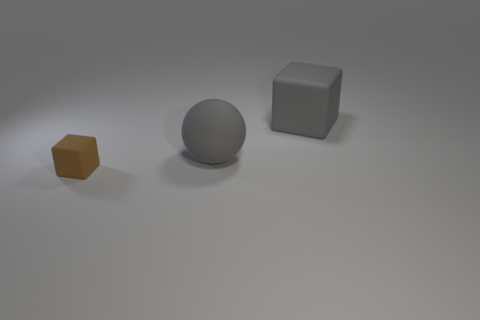Add 3 gray cubes. How many objects exist? 6 Subtract all blocks. How many objects are left? 1 Subtract 0 cyan spheres. How many objects are left? 3 Subtract all large objects. Subtract all small brown rubber things. How many objects are left? 0 Add 3 large gray rubber things. How many large gray rubber things are left? 5 Add 1 small metal cubes. How many small metal cubes exist? 1 